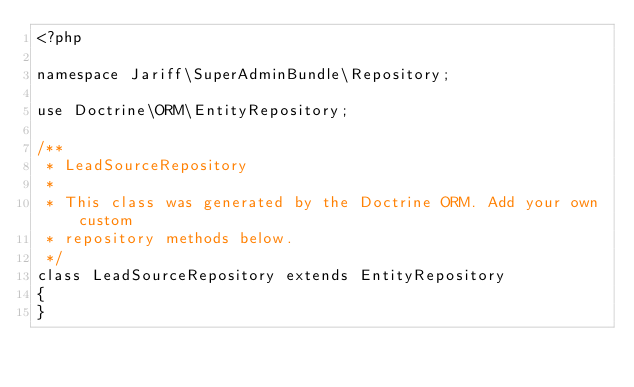Convert code to text. <code><loc_0><loc_0><loc_500><loc_500><_PHP_><?php

namespace Jariff\SuperAdminBundle\Repository;

use Doctrine\ORM\EntityRepository;

/**
 * LeadSourceRepository
 *
 * This class was generated by the Doctrine ORM. Add your own custom
 * repository methods below.
 */
class LeadSourceRepository extends EntityRepository
{
}
</code> 